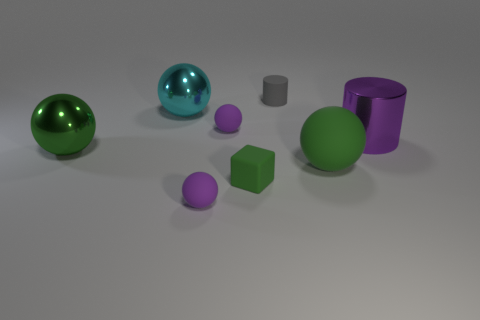Are the big green sphere that is right of the big cyan shiny object and the green sphere on the left side of the tiny matte block made of the same material?
Your response must be concise. No. There is a cylinder that is in front of the purple rubber thing behind the metallic ball in front of the cyan metal sphere; what color is it?
Give a very brief answer. Purple. What number of other objects are the same shape as the big purple metallic thing?
Provide a short and direct response. 1. Does the matte block have the same color as the big rubber object?
Provide a short and direct response. Yes. How many objects are purple rubber balls or tiny purple objects that are behind the green block?
Offer a very short reply. 2. Is there a green block that has the same size as the gray rubber cylinder?
Provide a short and direct response. Yes. Are the large purple cylinder and the small green thing made of the same material?
Your answer should be very brief. No. How many things are either big gray cubes or tiny purple objects?
Offer a very short reply. 2. How big is the purple shiny cylinder?
Your answer should be compact. Large. Are there fewer green rubber objects than big objects?
Keep it short and to the point. Yes. 